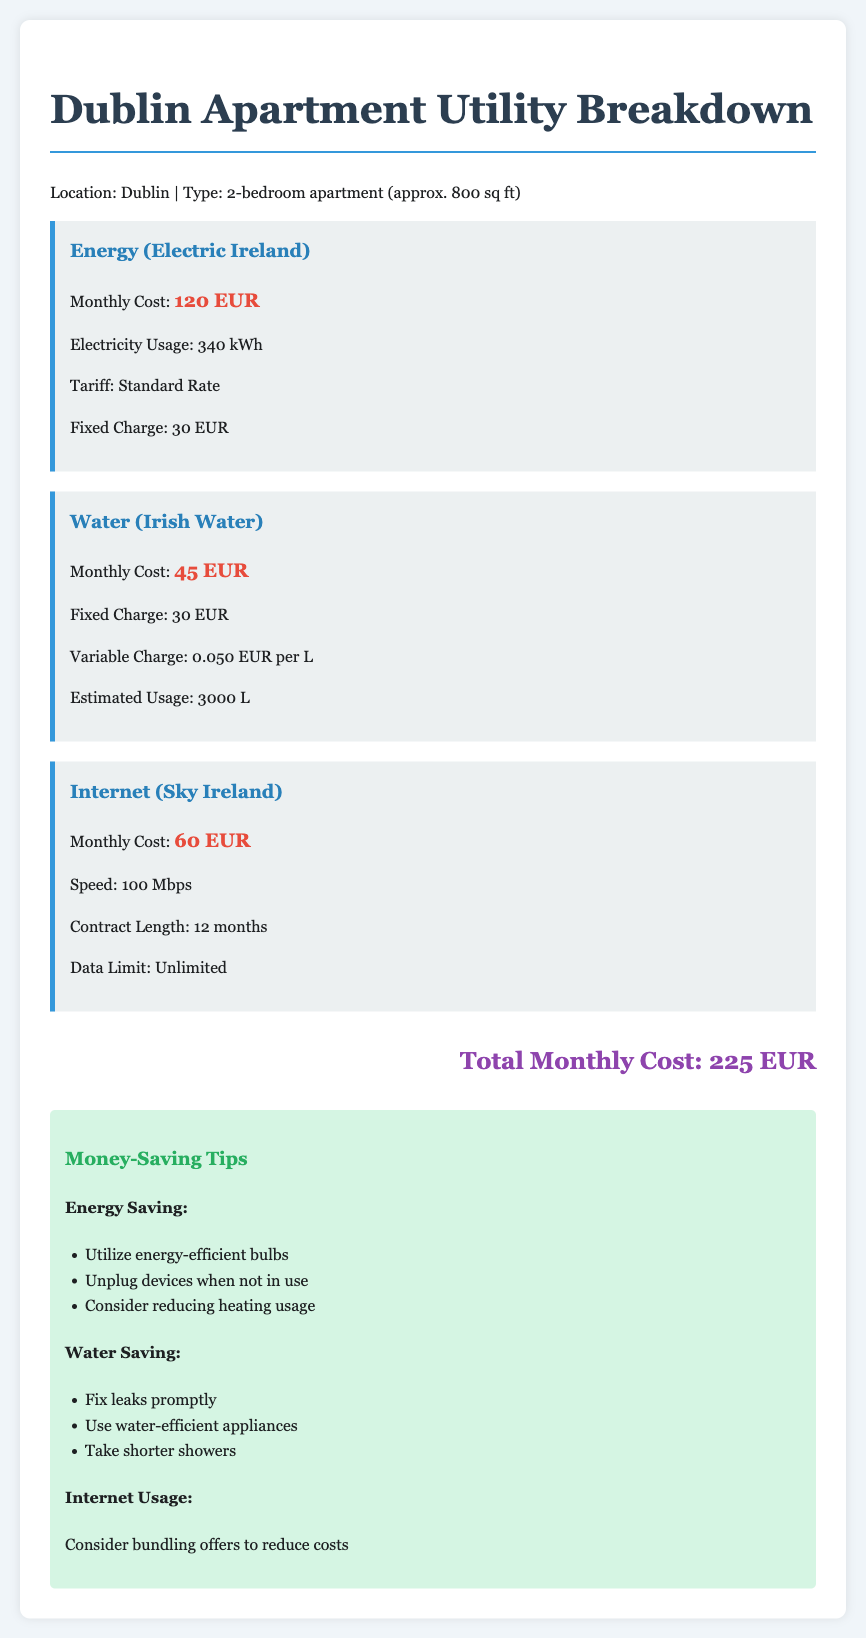What is the monthly cost for energy? The document states that the monthly cost for energy is 120 EUR.
Answer: 120 EUR What is the estimated water usage? The estimated water usage mentioned in the document is 3000 L.
Answer: 3000 L What is the fixed charge for internet? The document does not provide a fixed charge for internet. Instead, it states a contract length of 12 months.
Answer: Not specified What is the total monthly cost? The total monthly cost of utilities is calculated at the end of the document, which is 225 EUR.
Answer: 225 EUR What is the variable charge for water? The variable charge for water listed in the document is 0.050 EUR per L.
Answer: 0.050 EUR per L What is the speed of the internet? The document specifies that the internet speed is 100 Mbps.
Answer: 100 Mbps What savings tip is recommended for energy? The document suggests utilizing energy-efficient bulbs as a saving tip for energy.
Answer: Utilize energy-efficient bulbs What is included in the internet plan? The document mentions that the internet plan has unlimited data.
Answer: Unlimited What is the monthly cost for water? The document states that the monthly cost for water is 45 EUR.
Answer: 45 EUR What is the name of the energy provider? The document indicates that the energy provider is Electric Ireland.
Answer: Electric Ireland 